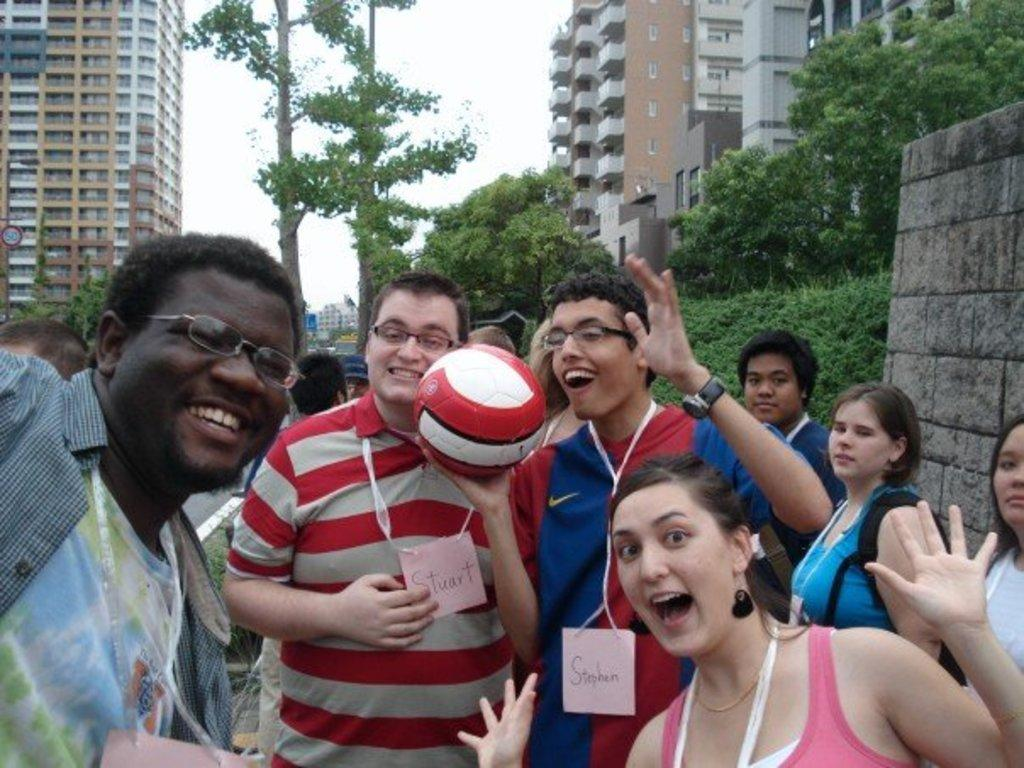How many people are in the image? There is a group of people in the image. What is one person holding in the image? One person is holding a ball. What can be seen in the background of the image? There are trees, a building, and the sky visible in the background of the image. What type of ring is being passed around in the image? There is no ring present in the image. What belief system do the people in the image follow? The provided facts do not give any information about the beliefs or religion of the people in the image. 